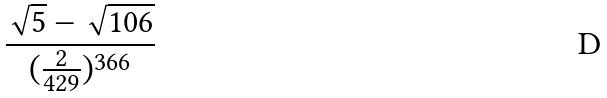<formula> <loc_0><loc_0><loc_500><loc_500>\frac { \sqrt { 5 } - \sqrt { 1 0 6 } } { ( \frac { 2 } { 4 2 9 } ) ^ { 3 6 6 } }</formula> 